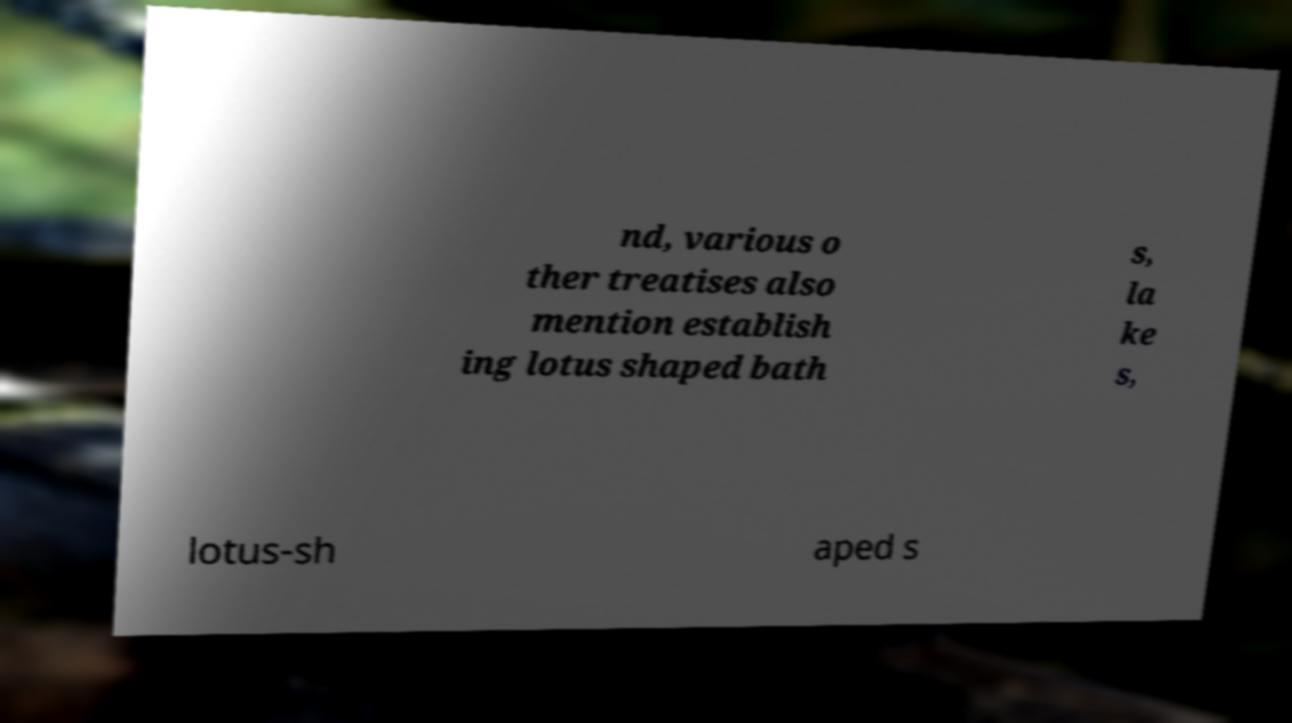There's text embedded in this image that I need extracted. Can you transcribe it verbatim? nd, various o ther treatises also mention establish ing lotus shaped bath s, la ke s, lotus-sh aped s 